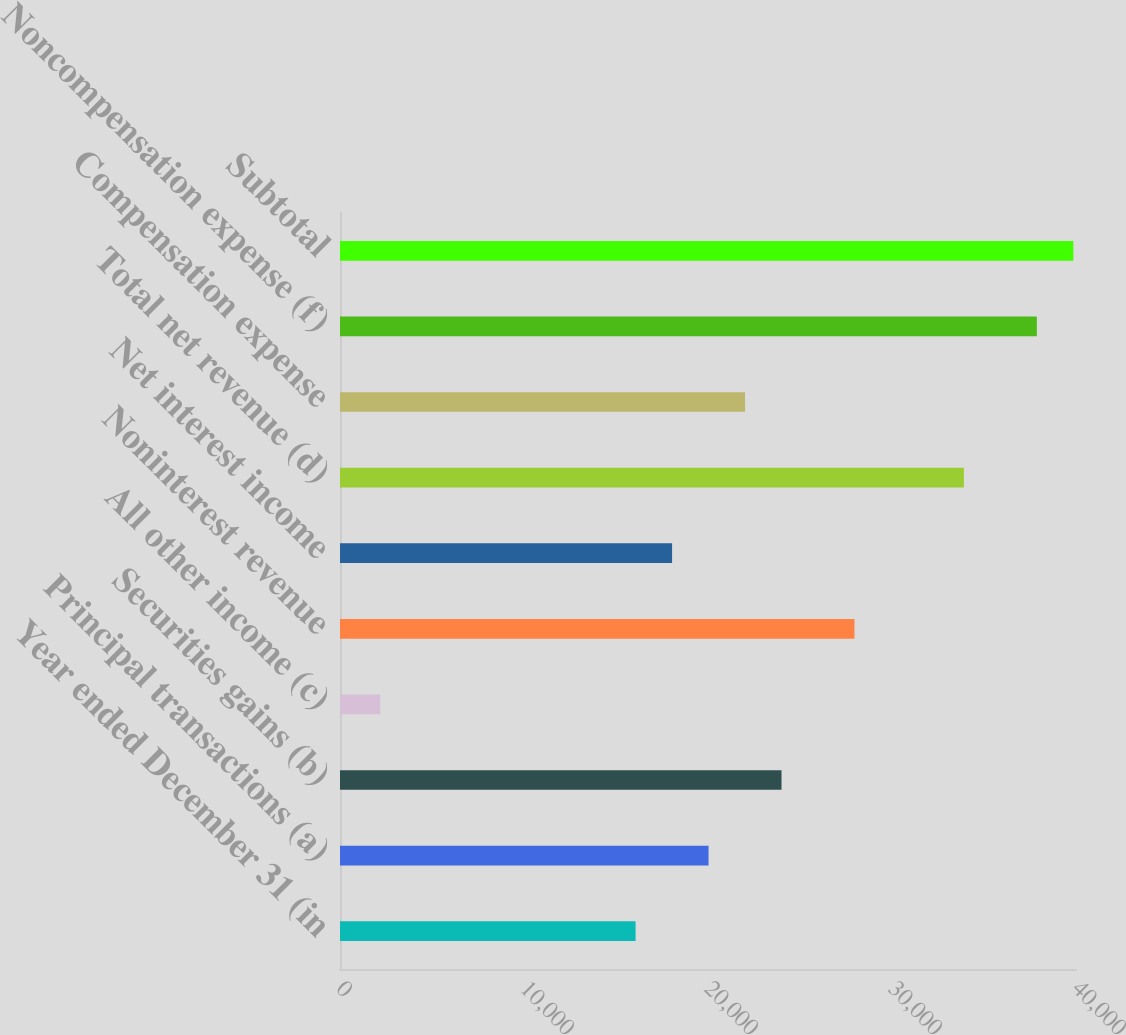Convert chart to OTSL. <chart><loc_0><loc_0><loc_500><loc_500><bar_chart><fcel>Year ended December 31 (in<fcel>Principal transactions (a)<fcel>Securities gains (b)<fcel>All other income (c)<fcel>Noninterest revenue<fcel>Net interest income<fcel>Total net revenue (d)<fcel>Compensation expense<fcel>Noncompensation expense (f)<fcel>Subtotal<nl><fcel>16065<fcel>20030<fcel>23995<fcel>2187.5<fcel>27960<fcel>18047.5<fcel>33907.5<fcel>22012.5<fcel>37872.5<fcel>39855<nl></chart> 